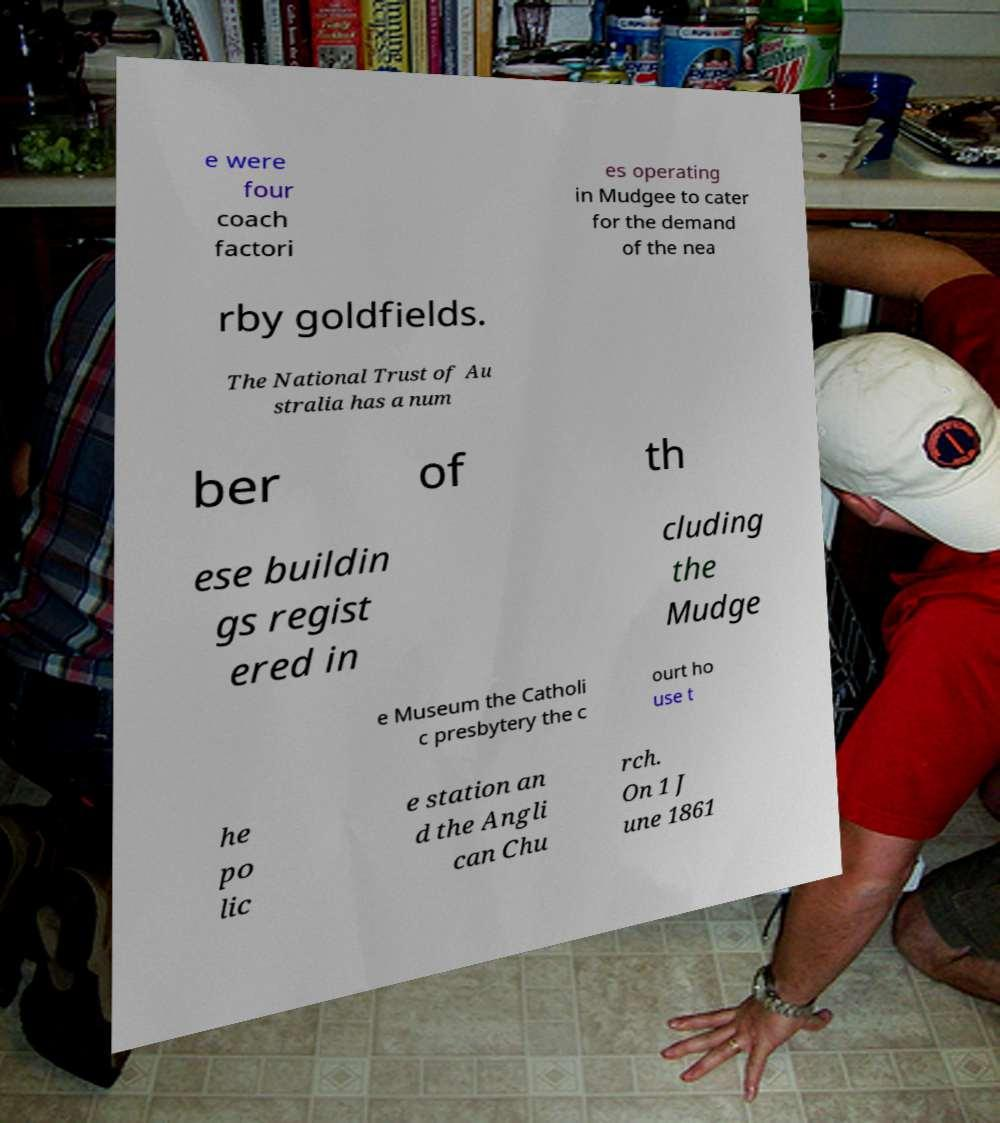For documentation purposes, I need the text within this image transcribed. Could you provide that? e were four coach factori es operating in Mudgee to cater for the demand of the nea rby goldfields. The National Trust of Au stralia has a num ber of th ese buildin gs regist ered in cluding the Mudge e Museum the Catholi c presbytery the c ourt ho use t he po lic e station an d the Angli can Chu rch. On 1 J une 1861 